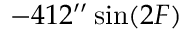<formula> <loc_0><loc_0><loc_500><loc_500>- 4 1 2 ^ { \prime \prime } \sin ( 2 F )</formula> 